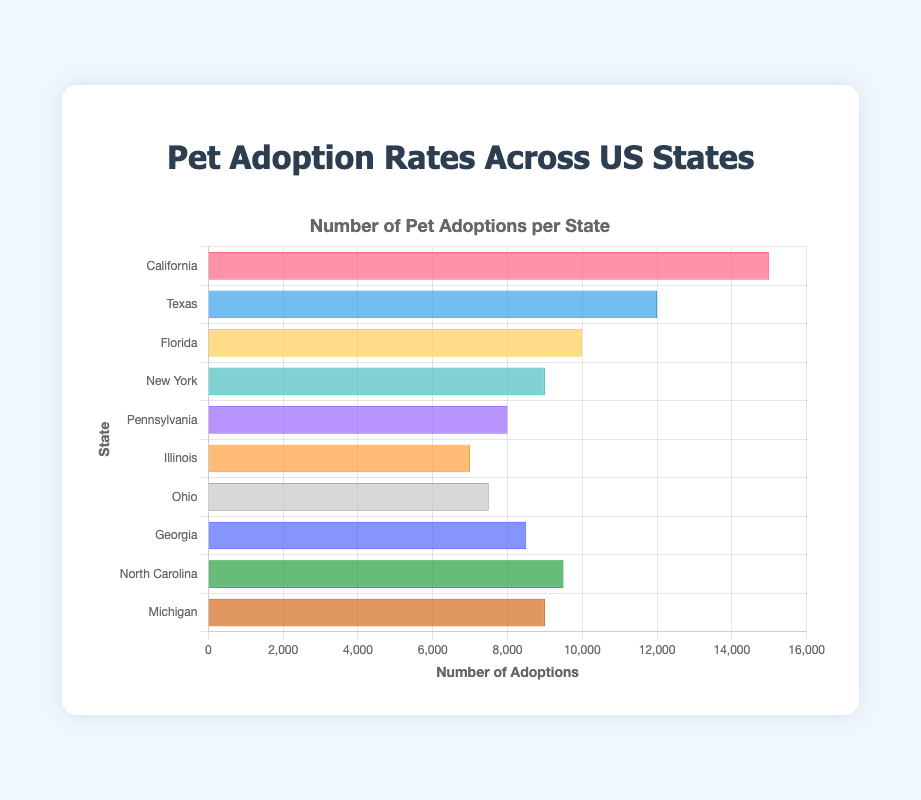Which state has the highest pet adoption rate? California's bar is the longest on the chart, indicating it has the highest adoption rate.
Answer: California What is the total number of pet adoptions in Texas and Florida combined? The adoption rates for Texas and Florida are 12,000 and 10,000, respectively. Adding them together, 12,000 + 10,000 = 22,000.
Answer: 22,000 Which state has a lower pet adoption rate, Illinois or Ohio? Comparing the lengths of the bars for Illinois and Ohio, Illinois has 7,000 adoptions while Ohio has 7,500 adoptions. Therefore, Illinois has a lower adoption rate.
Answer: Illinois What is the average pet adoption rate for New York, Pennsylvania, and Michigan? The adoption rates for New York, Pennsylvania, and Michigan are 9,000, 8,000, and 9,000, respectively. To find the average: (9,000 + 8,000 + 9,000) / 3 = 8,666.67.
Answer: 8,666.67 Which states have pet adoption rates above 10,000? By visually checking the chart, California and Texas are the only states with bars extending above the 10,000 mark.
Answer: California, Texas How much higher is California's pet adoption rate compared to New York's? California's adoption rate is 15,000, and New York's is 9,000. The difference is 15,000 - 9,000 = 6,000.
Answer: 6,000 List the states with adoption rates less than 9,000. The states with bars shorter than the 9,000 mark are Pennsylvania (8,000), Illinois (7,000), and Ohio (7,500).
Answer: Pennsylvania, Illinois, Ohio Which states have adoption rates between 8,000 and 10,000 inclusive? States with bars between 8,000 and 10,000 are Pennsylvania (8,000), Michigan (9,000), New York (9,000), and North Carolina (9,500).
Answer: Pennsylvania, New York, North Carolina, Michigan What is the difference in the number of pet adoptions between Georgia and North Carolina? Georgia has 8,500 adoptions, while North Carolina has 9,500. The difference is 9,500 - 8,500 = 1,000.
Answer: 1,000 